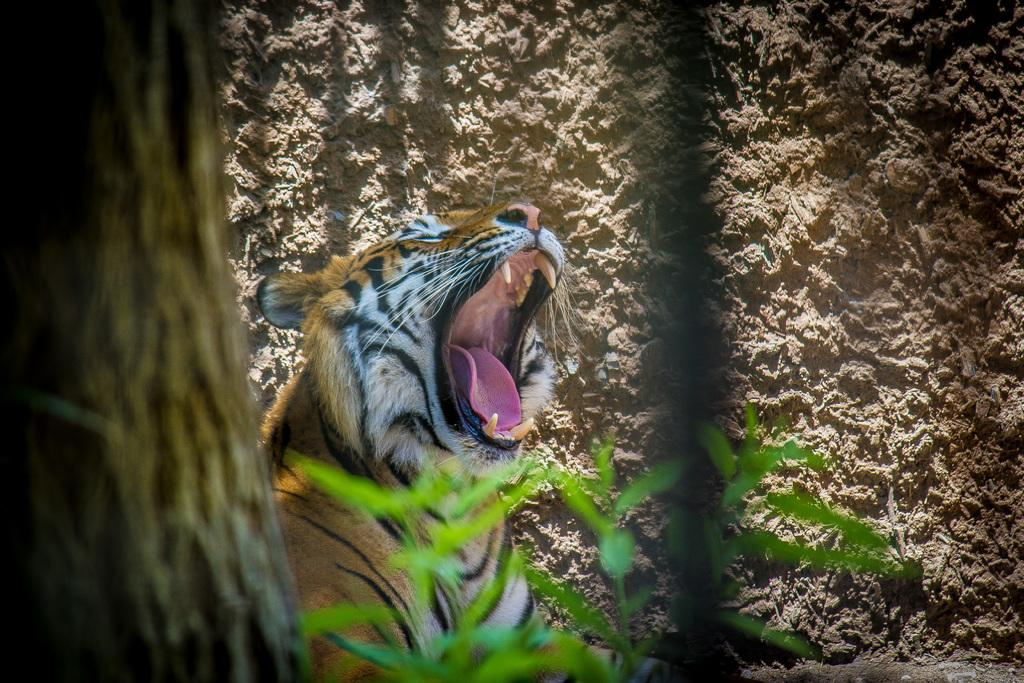What type of animal is in the image? There is a tiger in the image. Where is the tree located in the image? There is a tree on the left side of the image. What can be seen on the tree's surface? Tree bark is visible on the tree. What is present at the bottom of the image? Leaves are present at the bottom of the image. What can be seen in the background of the image? There is a wall in the background of the image. What type of cannon is being fired in the image? There is no cannon present in the image; it features a tiger and a tree. What joke is the tiger telling in the image? There is no indication of a joke being told in the image; it simply shows a tiger and a tree. 